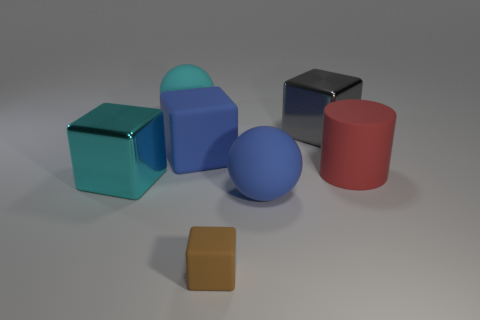What shape is the cyan rubber object that is the same size as the blue cube?
Give a very brief answer. Sphere. There is a gray thing; what number of big spheres are behind it?
Your answer should be very brief. 1. Do the large cube that is in front of the large red matte object and the cyan object behind the large gray shiny thing have the same material?
Offer a very short reply. No. Is the number of big red matte things in front of the large cyan metal block greater than the number of big shiny objects that are to the right of the big red matte thing?
Offer a very short reply. No. What is the material of the thing that is the same color as the large rubber block?
Your response must be concise. Rubber. Are there any other things that have the same shape as the small brown matte object?
Offer a terse response. Yes. What is the thing that is both right of the large blue sphere and in front of the gray metallic object made of?
Offer a terse response. Rubber. Are the big blue ball and the blue object that is behind the large red cylinder made of the same material?
Keep it short and to the point. Yes. Is there anything else that is the same size as the blue sphere?
Provide a succinct answer. Yes. What number of things are large cyan metal spheres or big metallic cubes on the left side of the large blue matte ball?
Give a very brief answer. 1. 